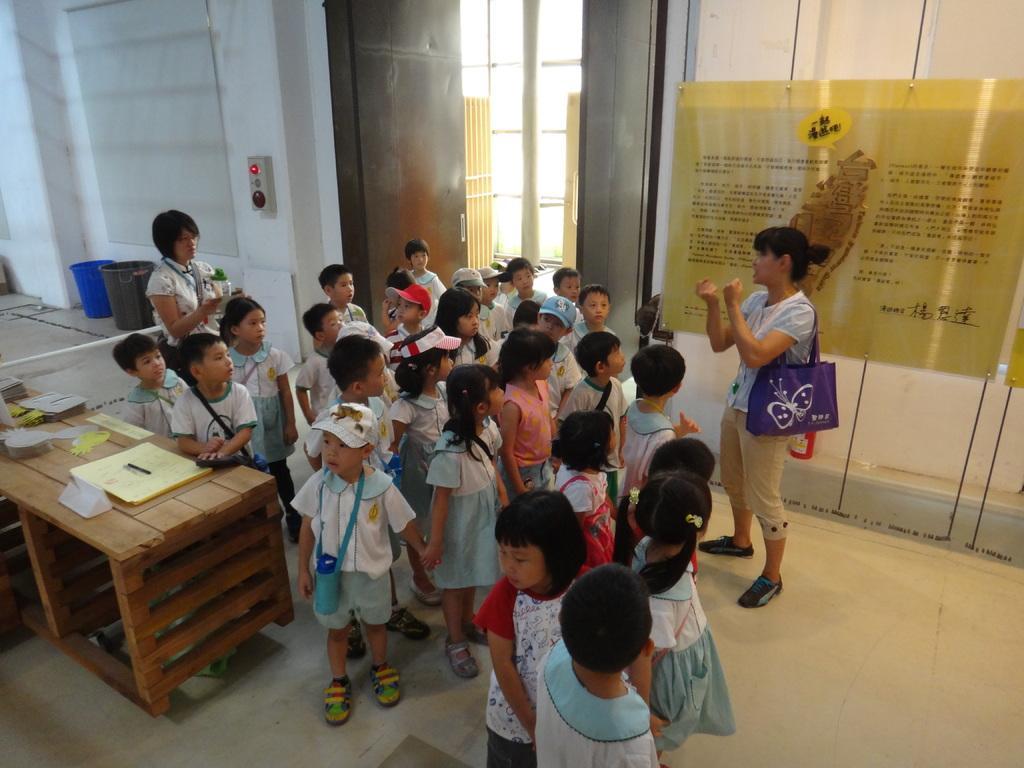Please provide a concise description of this image. As we can see in he image there is a wall, poster, few people standing on floor, table and dustbins. 